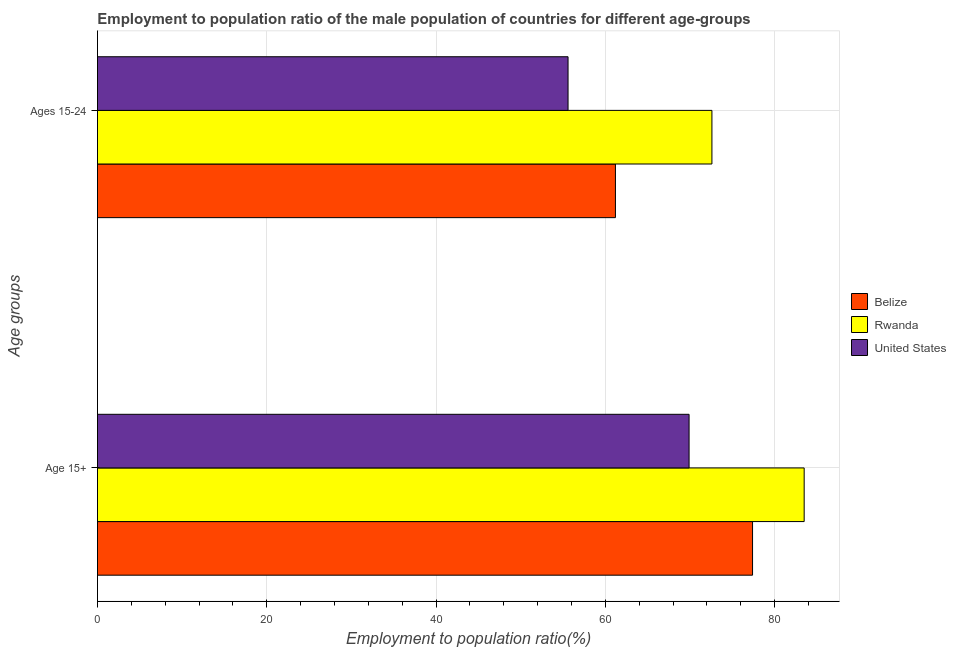How many groups of bars are there?
Make the answer very short. 2. Are the number of bars per tick equal to the number of legend labels?
Make the answer very short. Yes. Are the number of bars on each tick of the Y-axis equal?
Your answer should be very brief. Yes. What is the label of the 2nd group of bars from the top?
Your response must be concise. Age 15+. What is the employment to population ratio(age 15-24) in Belize?
Offer a terse response. 61.2. Across all countries, what is the maximum employment to population ratio(age 15-24)?
Your answer should be very brief. 72.6. Across all countries, what is the minimum employment to population ratio(age 15+)?
Your answer should be very brief. 69.9. In which country was the employment to population ratio(age 15+) maximum?
Provide a short and direct response. Rwanda. What is the total employment to population ratio(age 15-24) in the graph?
Your answer should be compact. 189.4. What is the difference between the employment to population ratio(age 15-24) in United States and that in Rwanda?
Offer a terse response. -17. What is the difference between the employment to population ratio(age 15+) in Rwanda and the employment to population ratio(age 15-24) in Belize?
Provide a short and direct response. 22.3. What is the average employment to population ratio(age 15-24) per country?
Make the answer very short. 63.13. What is the difference between the employment to population ratio(age 15-24) and employment to population ratio(age 15+) in Rwanda?
Provide a short and direct response. -10.9. In how many countries, is the employment to population ratio(age 15+) greater than 4 %?
Offer a terse response. 3. What is the ratio of the employment to population ratio(age 15-24) in Belize to that in United States?
Make the answer very short. 1.1. Is the employment to population ratio(age 15+) in Rwanda less than that in Belize?
Give a very brief answer. No. What does the 2nd bar from the top in Age 15+ represents?
Your answer should be compact. Rwanda. What does the 1st bar from the bottom in Age 15+ represents?
Offer a very short reply. Belize. How many bars are there?
Offer a terse response. 6. How many countries are there in the graph?
Give a very brief answer. 3. Are the values on the major ticks of X-axis written in scientific E-notation?
Your answer should be very brief. No. How are the legend labels stacked?
Keep it short and to the point. Vertical. What is the title of the graph?
Offer a terse response. Employment to population ratio of the male population of countries for different age-groups. What is the label or title of the Y-axis?
Provide a short and direct response. Age groups. What is the Employment to population ratio(%) of Belize in Age 15+?
Keep it short and to the point. 77.4. What is the Employment to population ratio(%) in Rwanda in Age 15+?
Provide a succinct answer. 83.5. What is the Employment to population ratio(%) in United States in Age 15+?
Your answer should be compact. 69.9. What is the Employment to population ratio(%) of Belize in Ages 15-24?
Provide a succinct answer. 61.2. What is the Employment to population ratio(%) in Rwanda in Ages 15-24?
Offer a terse response. 72.6. What is the Employment to population ratio(%) in United States in Ages 15-24?
Provide a short and direct response. 55.6. Across all Age groups, what is the maximum Employment to population ratio(%) of Belize?
Your response must be concise. 77.4. Across all Age groups, what is the maximum Employment to population ratio(%) in Rwanda?
Provide a succinct answer. 83.5. Across all Age groups, what is the maximum Employment to population ratio(%) of United States?
Offer a very short reply. 69.9. Across all Age groups, what is the minimum Employment to population ratio(%) of Belize?
Offer a terse response. 61.2. Across all Age groups, what is the minimum Employment to population ratio(%) of Rwanda?
Your answer should be compact. 72.6. Across all Age groups, what is the minimum Employment to population ratio(%) of United States?
Offer a very short reply. 55.6. What is the total Employment to population ratio(%) in Belize in the graph?
Ensure brevity in your answer.  138.6. What is the total Employment to population ratio(%) in Rwanda in the graph?
Your response must be concise. 156.1. What is the total Employment to population ratio(%) in United States in the graph?
Offer a terse response. 125.5. What is the difference between the Employment to population ratio(%) in Belize in Age 15+ and that in Ages 15-24?
Your answer should be compact. 16.2. What is the difference between the Employment to population ratio(%) of United States in Age 15+ and that in Ages 15-24?
Ensure brevity in your answer.  14.3. What is the difference between the Employment to population ratio(%) in Belize in Age 15+ and the Employment to population ratio(%) in United States in Ages 15-24?
Make the answer very short. 21.8. What is the difference between the Employment to population ratio(%) of Rwanda in Age 15+ and the Employment to population ratio(%) of United States in Ages 15-24?
Ensure brevity in your answer.  27.9. What is the average Employment to population ratio(%) of Belize per Age groups?
Provide a succinct answer. 69.3. What is the average Employment to population ratio(%) in Rwanda per Age groups?
Provide a succinct answer. 78.05. What is the average Employment to population ratio(%) in United States per Age groups?
Provide a succinct answer. 62.75. What is the difference between the Employment to population ratio(%) in Belize and Employment to population ratio(%) in Rwanda in Age 15+?
Your answer should be very brief. -6.1. What is the difference between the Employment to population ratio(%) in Belize and Employment to population ratio(%) in United States in Age 15+?
Provide a succinct answer. 7.5. What is the difference between the Employment to population ratio(%) of Rwanda and Employment to population ratio(%) of United States in Age 15+?
Your response must be concise. 13.6. What is the difference between the Employment to population ratio(%) in Rwanda and Employment to population ratio(%) in United States in Ages 15-24?
Make the answer very short. 17. What is the ratio of the Employment to population ratio(%) in Belize in Age 15+ to that in Ages 15-24?
Ensure brevity in your answer.  1.26. What is the ratio of the Employment to population ratio(%) in Rwanda in Age 15+ to that in Ages 15-24?
Your answer should be very brief. 1.15. What is the ratio of the Employment to population ratio(%) in United States in Age 15+ to that in Ages 15-24?
Provide a succinct answer. 1.26. What is the difference between the highest and the second highest Employment to population ratio(%) in Belize?
Offer a terse response. 16.2. What is the difference between the highest and the lowest Employment to population ratio(%) in United States?
Your answer should be very brief. 14.3. 